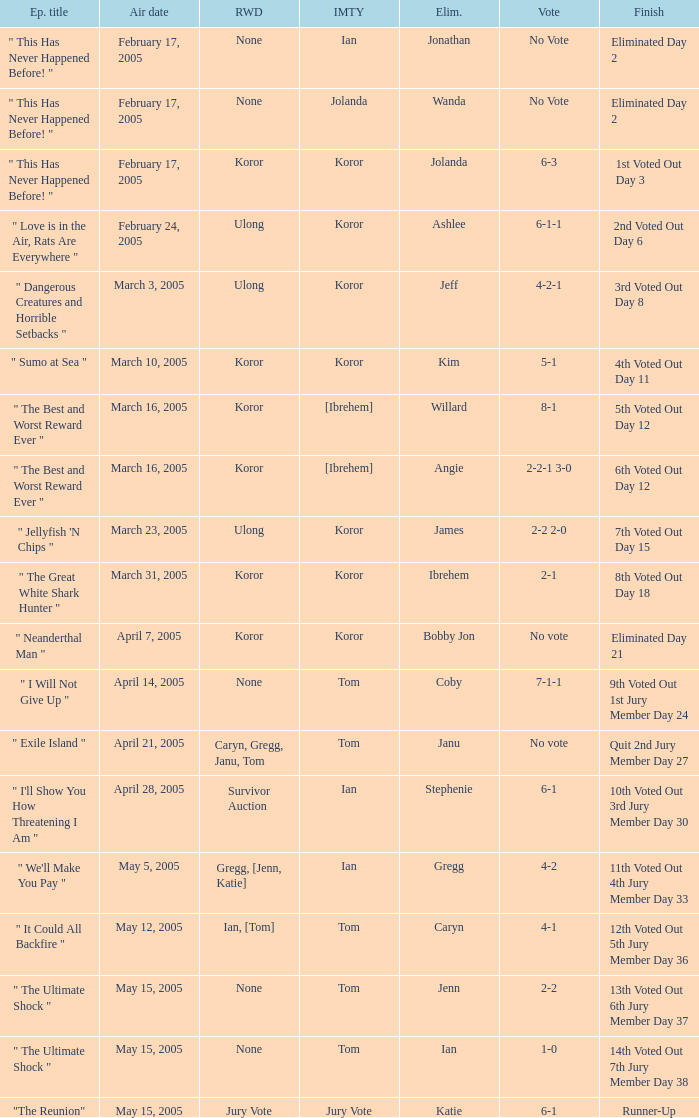What was the vote tally on the episode aired May 5, 2005? 4-2. 